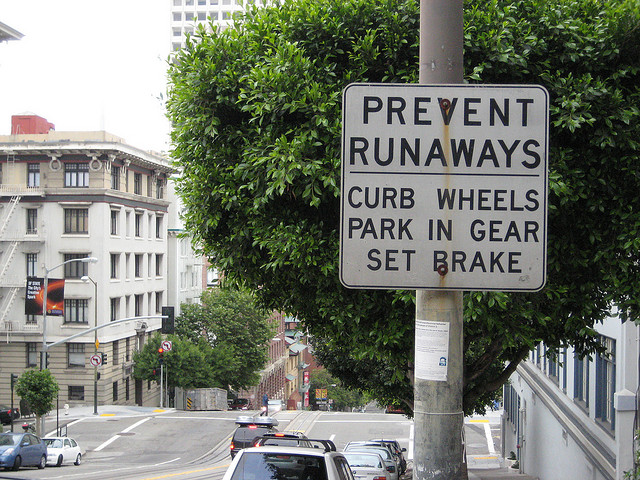Please transcribe the text information in this image. RUNAWAYS CURB WHEELS IN GEAR PARK BRAKE SET PREVENT 